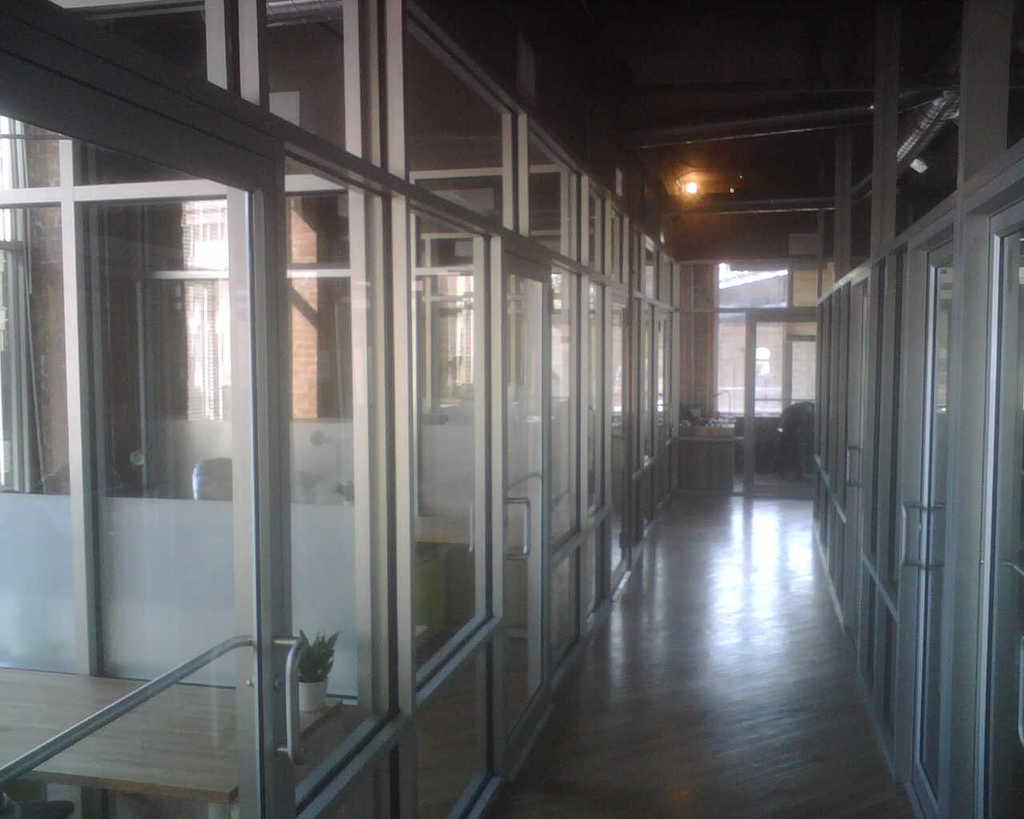What type of location is depicted in the image? The image is an inside view of a building. What kind of rooms or spaces can be seen in the image? There are cabins with glass doors in the image. Are there any natural elements present in the image? Yes, there is a plant in the image. What type of furniture is visible in the image? There are tables in the image. Are there any window treatments in the image? Yes, there are curtains in the image. Can you hear the beetle crying in the image? There is no beetle or any indication of crying in the image. 